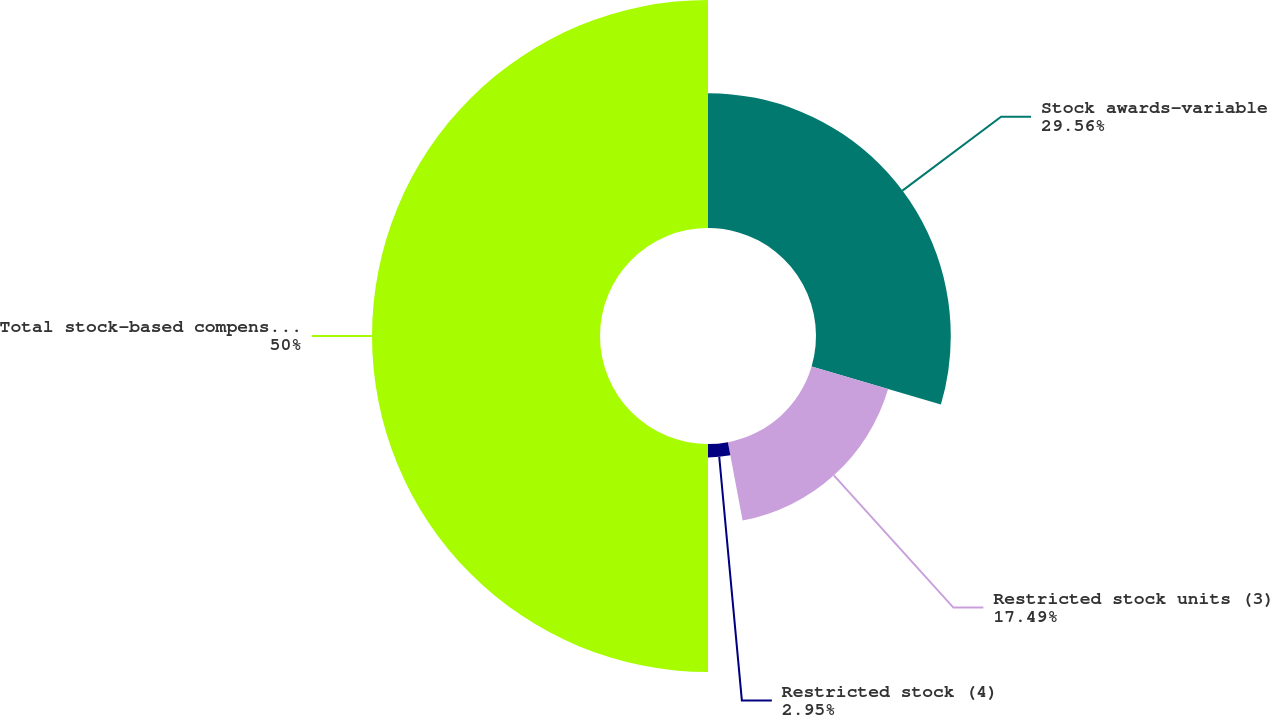Convert chart. <chart><loc_0><loc_0><loc_500><loc_500><pie_chart><fcel>Stock awards-variable<fcel>Restricted stock units (3)<fcel>Restricted stock (4)<fcel>Total stock-based compensation<nl><fcel>29.56%<fcel>17.49%<fcel>2.95%<fcel>50.0%<nl></chart> 